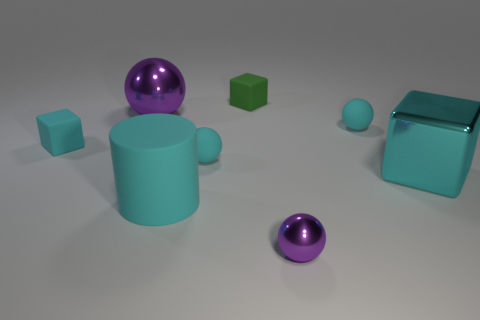Can you describe the colors and shapes of the objects in the image? Certainly! In the image, we have objects in a range of shapes including spheres, cubes, and cylinders. The colors visible are cyan, green, and purple. There's a large cyan cylinder with a glossy finish next to two glossy purple spheres, and two green cubes with what looks like a matte finish. 